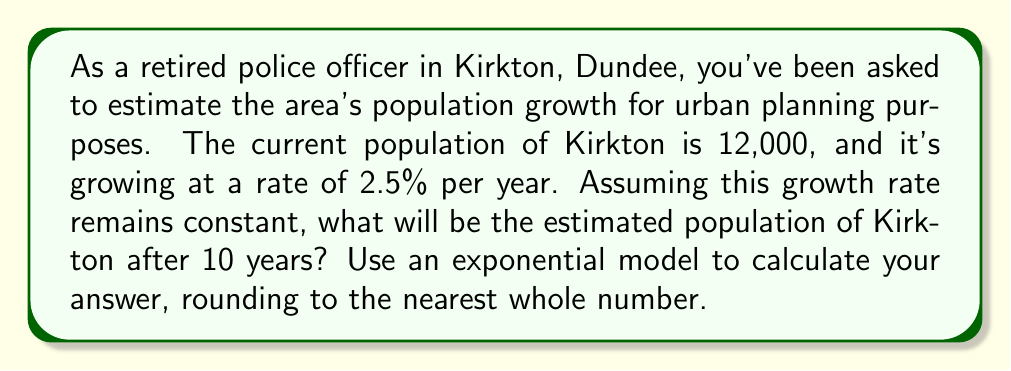Solve this math problem. To solve this problem, we'll use an exponential growth model. The general form of an exponential growth model is:

$$P(t) = P_0 \cdot (1 + r)^t$$

Where:
$P(t)$ is the population at time $t$
$P_0$ is the initial population
$r$ is the growth rate (as a decimal)
$t$ is the time in years

Given:
$P_0 = 12,000$ (initial population)
$r = 0.025$ (2.5% growth rate as a decimal)
$t = 10$ years

Let's plug these values into our equation:

$$P(10) = 12,000 \cdot (1 + 0.025)^{10}$$

Now, let's solve this step-by-step:

1) First, calculate $(1 + 0.025)^{10}$:
   $$(1.025)^{10} \approx 1.2800975$$

2) Now multiply this by the initial population:
   $$12,000 \cdot 1.2800975 \approx 15,361.17$$

3) Rounding to the nearest whole number:
   $$15,361$$

Therefore, after 10 years, the estimated population of Kirkton will be 15,361 people.
Answer: 15,361 people 